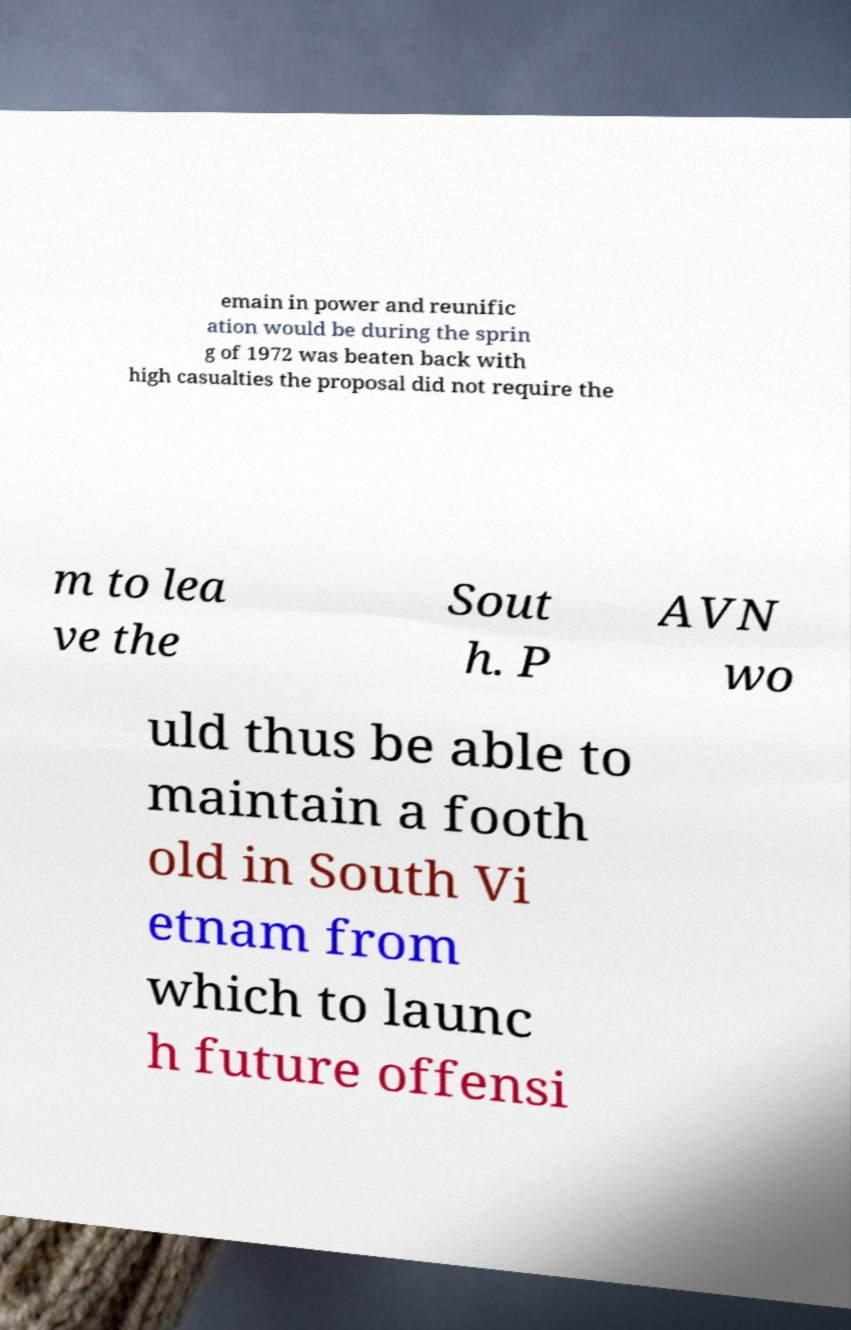For documentation purposes, I need the text within this image transcribed. Could you provide that? emain in power and reunific ation would be during the sprin g of 1972 was beaten back with high casualties the proposal did not require the m to lea ve the Sout h. P AVN wo uld thus be able to maintain a footh old in South Vi etnam from which to launc h future offensi 